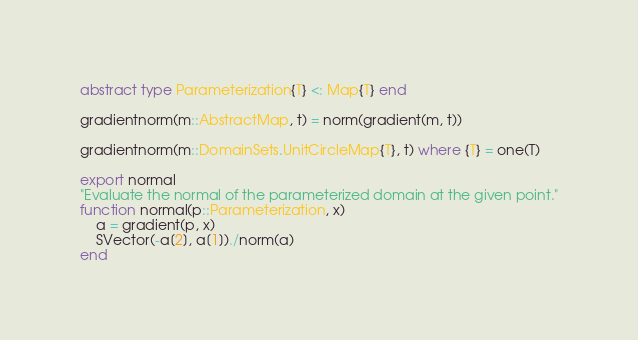<code> <loc_0><loc_0><loc_500><loc_500><_Julia_>
abstract type Parameterization{T} <: Map{T} end

gradientnorm(m::AbstractMap, t) = norm(gradient(m, t))

gradientnorm(m::DomainSets.UnitCircleMap{T}, t) where {T} = one(T)

export normal
"Evaluate the normal of the parameterized domain at the given point."
function normal(p::Parameterization, x)
    a = gradient(p, x)
    SVector(-a[2], a[1])./norm(a)
end
</code> 